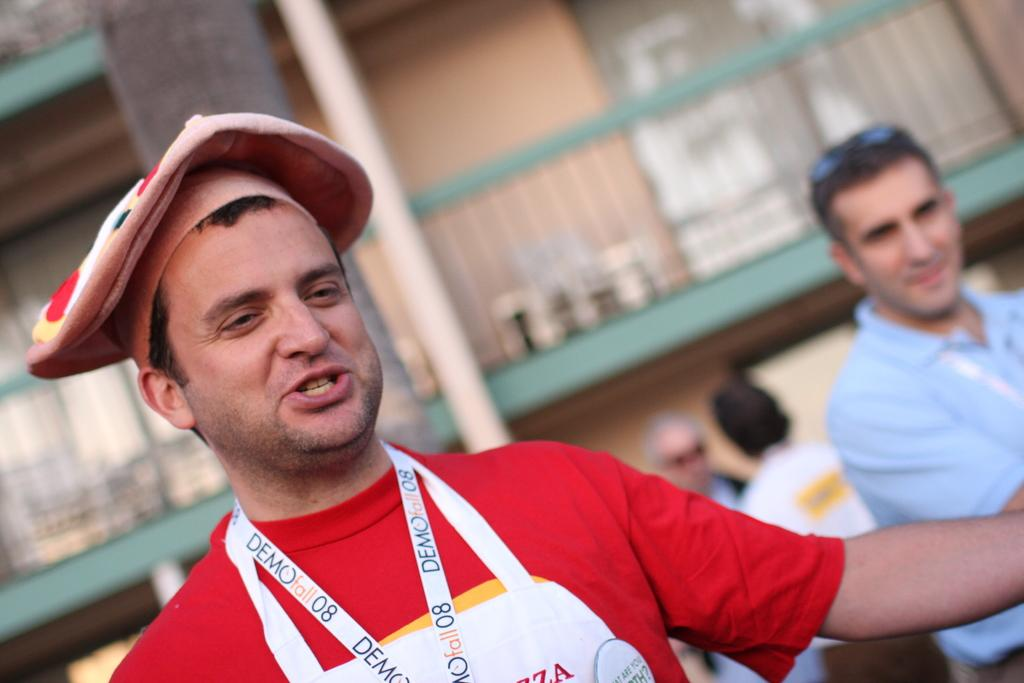<image>
Offer a succinct explanation of the picture presented. Man wearing a necklace which says Demofall08 on it. 